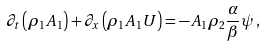<formula> <loc_0><loc_0><loc_500><loc_500>\partial _ { t } \left ( \rho _ { 1 } A _ { 1 } \right ) + \partial _ { x } \left ( \rho _ { 1 } A _ { 1 } U \right ) = - A _ { 1 } \rho _ { 2 } \frac { \alpha } { \beta } \psi \, ,</formula> 